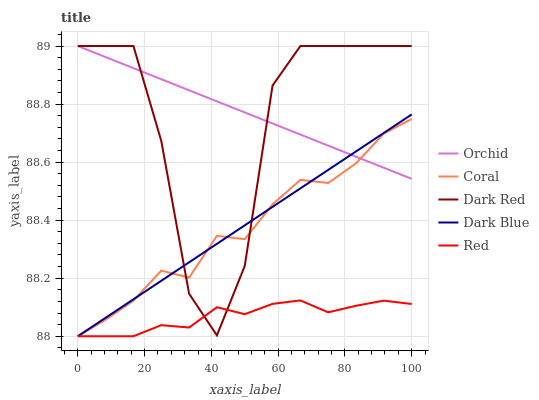Does Red have the minimum area under the curve?
Answer yes or no. Yes. Does Orchid have the maximum area under the curve?
Answer yes or no. Yes. Does Coral have the minimum area under the curve?
Answer yes or no. No. Does Coral have the maximum area under the curve?
Answer yes or no. No. Is Dark Blue the smoothest?
Answer yes or no. Yes. Is Dark Red the roughest?
Answer yes or no. Yes. Is Coral the smoothest?
Answer yes or no. No. Is Coral the roughest?
Answer yes or no. No. Does Coral have the lowest value?
Answer yes or no. Yes. Does Orchid have the lowest value?
Answer yes or no. No. Does Orchid have the highest value?
Answer yes or no. Yes. Does Coral have the highest value?
Answer yes or no. No. Is Red less than Orchid?
Answer yes or no. Yes. Is Orchid greater than Red?
Answer yes or no. Yes. Does Coral intersect Red?
Answer yes or no. Yes. Is Coral less than Red?
Answer yes or no. No. Is Coral greater than Red?
Answer yes or no. No. Does Red intersect Orchid?
Answer yes or no. No. 